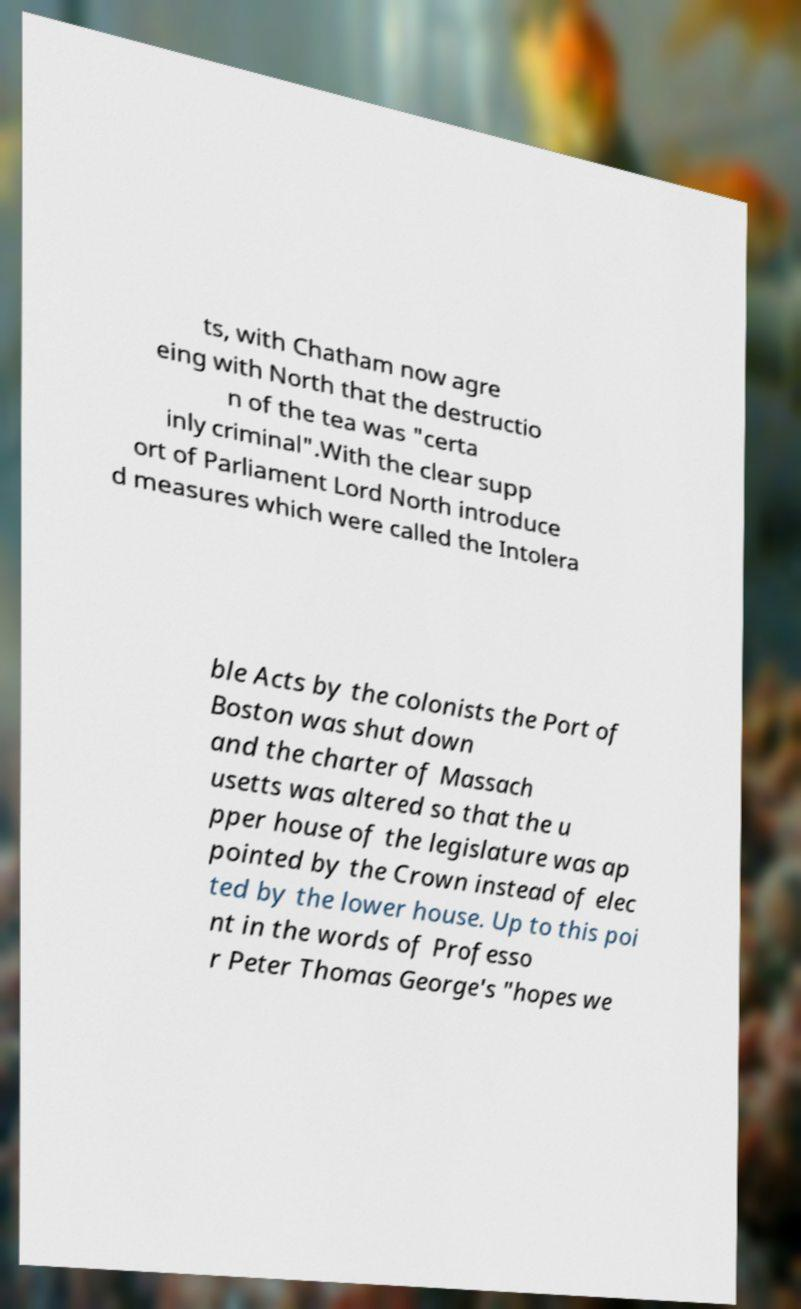There's text embedded in this image that I need extracted. Can you transcribe it verbatim? ts, with Chatham now agre eing with North that the destructio n of the tea was "certa inly criminal".With the clear supp ort of Parliament Lord North introduce d measures which were called the Intolera ble Acts by the colonists the Port of Boston was shut down and the charter of Massach usetts was altered so that the u pper house of the legislature was ap pointed by the Crown instead of elec ted by the lower house. Up to this poi nt in the words of Professo r Peter Thomas George's "hopes we 